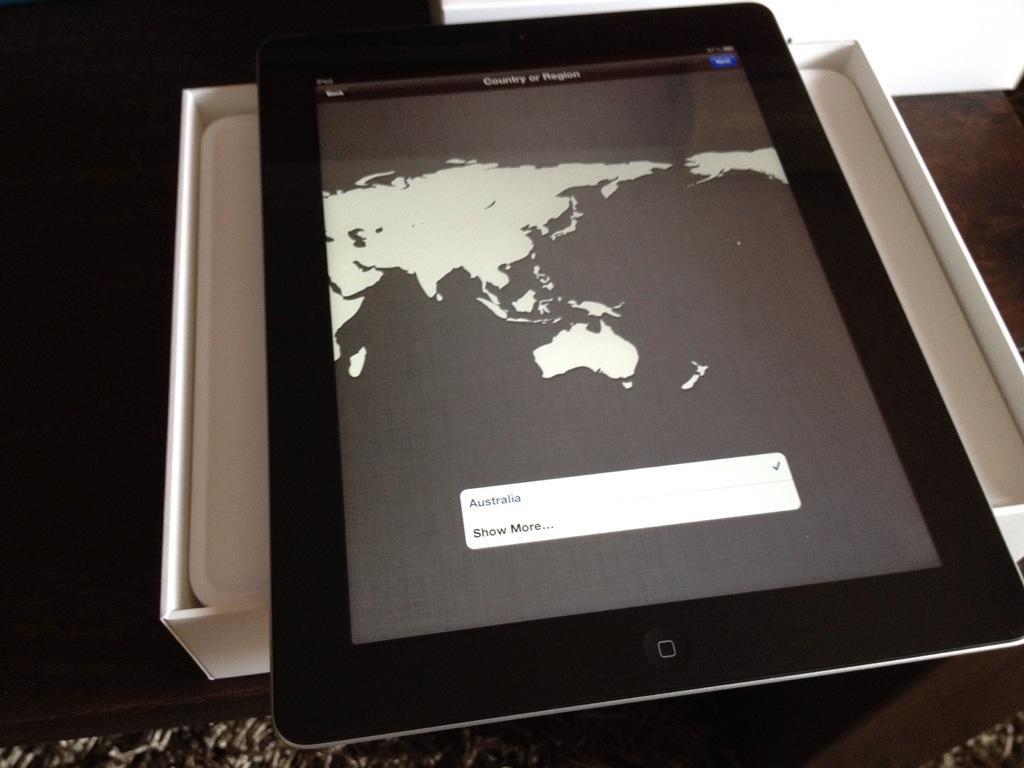In one or two sentences, can you explain what this image depicts? In the image we can see there is a tablet which is kept on the its box. 